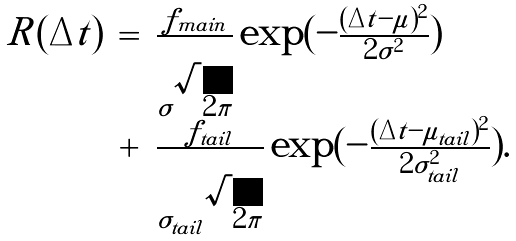Convert formula to latex. <formula><loc_0><loc_0><loc_500><loc_500>\begin{array} { l c l } R ( \Delta t ) & = & \frac { f _ { m a i n } } { \sigma \sqrt { 2 \pi } } \exp ( - \frac { ( \Delta t - \mu ) ^ { 2 } } { 2 \sigma ^ { 2 } } ) \\ & + & \frac { f _ { t a i l } } { \sigma _ { t a i l } \sqrt { 2 \pi } } \exp ( - \frac { ( \Delta t - \mu _ { t a i l } ) ^ { 2 } } { 2 \sigma _ { t a i l } ^ { 2 } } ) . \end{array}</formula> 